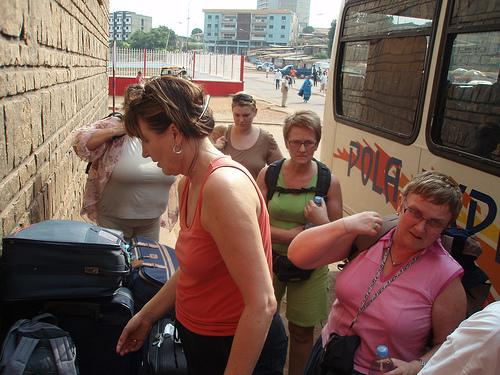What is the subject matter of this image in the context of a travel scenario? In a travel context, the image depicts passengers with their luggage, ready to embark on a journey via a tour bus. What is the primary activity of the people in the image? Passengers are getting ready to board a bus and collect their luggage. Identify the type of vehicle seen in the image, and describe its role in the context. A tour bus is waiting for passengers to board and collect their luggage. Please describe the location where this image is captured, including any noticeable environmental features. The image is taken in a street with passengers walking, buildings in the background, and luggage piled against a brown brick wall. What types of accessories can be observed in the image? Accessories include hair clips, sunglasses, pierced earrings, lanyards, fanny packs, and backpacks. Examine the image for any anomalies or unusual details. An unusual detail in the image is the bottle of water with a blue cap, positioned oddly among the passengers preparing for their trip. Can you describe the scene with the luggage in the image? There's a pile of luggage including a blue suitcase, placed next to a brown brick wall, waiting to be collected by its owners. Describe the different building structures visible in the image. There are four-story light blue apartment buildings and white and tan buildings in the background. In this picture, point out the presence of eyeglasses and discuss their usage. Both women are wearing eyeglasses, which are used to enhance their vision. Please provide a description of the different clothing items worn by the women in the image. The women are wearing colorful sleeveless shirts and tank tops, green shorts, and one has a lanyard around her neck. Find a large red and blue flag hanging from one of the buildings. There are buildings in the image, but there is no mention of a large red and blue flag hanging from any of them. In the scene with bus passengers, what kind of identification accessory is worn by one of the women? Lanyard around her neck Describe the main elements of the buildings in the background. White and tan building, four-story light blue apartment building, brown brick wall Is there a logo visible on the side of the bus? Yes, orange blue and yellow logo Identify a small child playing with a toy nearby the women. The presence of women is confirmed in the image, but there is no information about a small child playing with a toy nearby. What type of clothing are the two women in the image wearing? Both women wear eyeglasses Are the people walking in the background carrying umbrellas? There are people walking in the background; however, there is no information about them carrying umbrellas. What is the dominant color of the luggage in the pile? Brown and blue What type of earrings does the woman wear in the image? Silver hoop earrings Notice the big fountain located between the buildings in the background. Buildings are mentioned in the background of the image, but there is no mention of a fountain between them. Describe the accessories worn by the women in the image. Hair clip, sunglasses, pierced earrings, lanyard, hoop earrings Observe the green tree standing next to the four-story light blue apartment building. While there is a four-story light blue apartment building in the image, there is no mention of a green tree standing next to it. Which of these items is in the image? A) Luggage pile B) Airplane C) Bicycle A) Luggage pile What is the primary object in the center of the image? Bus passengers ready to board the bus Are there any bicycles parked near the brown brick wall? There is a brown brick wall in the image; however, there is no indication of any bicycles parked nearby. What is the activity that the passengers are engaging in? Boarding a bus Who is mentioned as carrying a large backpack in the image? A passenger What type of transportation vehicle is waiting for the passengers? Bus What event is taking place involving the pile of luggage? Passengers collecting luggage Describe the type of buildings visible behind the bus passengers. Brown brick wall and white and tan buildings Find the bus passengers sitting inside the bus. The presence of bus passengers in the image is confirmed; however, they are ready to board the bus and not sitting inside it. Spot the yellow taxi parked near the white tourist passenger van. A white tourist passenger van is present in the image, but there is no information about a yellow taxi parked nearby. Describe the image while focusing on the objects and their locations. Bus passengers near bus, luggage pile next to brick wall, water bottle with blue lid, women wearing eyeglasses and various accessories Spot a man wearing a bright red shirt. There is a mention of a woman wearing a red top, but there is no information about a man wearing a red shirt in the image. What can be observed about the women's hair in the image? They all have short hair Is there a black cat sitting on the pile of luggage? There is a pile of luggage in the image, but there is no mention of a black cat sitting on it. What is the color and style of the water bottle in the image? Blue lid, clear colored Create a multi-modal description of the scene with the bus passengers and luggage pile. A busy street with bus passengers preparing to board their bus, a pile of luggage nearby, and buildings in the background. What color is the sleeveless shirt the older woman is wearing? Pink 